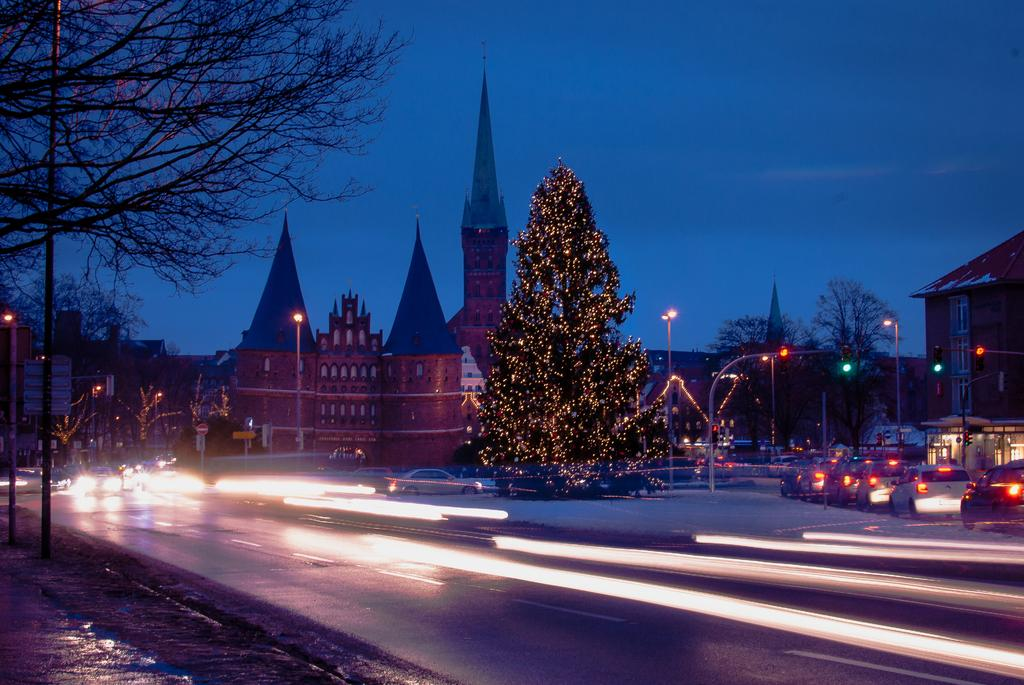What type of facility is present in the image? There is a WC in the image. What festive decoration can be seen in the image? There is a decorated Christmas tree in the image. What type of structures are visible in the image? There are buildings in the image. What type of street furniture is present in the image? Street poles and street lights are visible in the image. What type of transportation is present in the image? Motor vehicles are on the road in the image. What type of natural elements are visible in the image? Trees are visible in the image. What part of the natural environment is visible in the image? The sky is visible in the image. How many children are playing in the snow in the image? There is no snow or children present in the image. What type of motion can be seen in the image? The image is a still photograph, so there is no motion visible. 